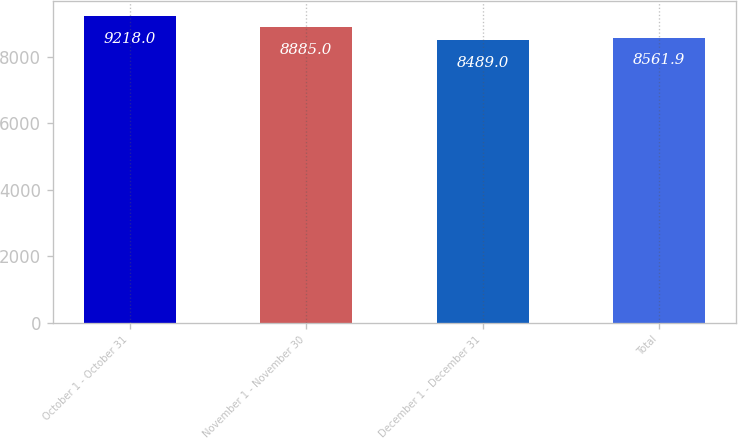<chart> <loc_0><loc_0><loc_500><loc_500><bar_chart><fcel>October 1 - October 31<fcel>November 1 - November 30<fcel>December 1 - December 31<fcel>Total<nl><fcel>9218<fcel>8885<fcel>8489<fcel>8561.9<nl></chart> 